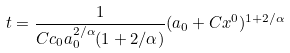<formula> <loc_0><loc_0><loc_500><loc_500>t = \frac { 1 } { C c _ { 0 } a _ { 0 } ^ { 2 / \alpha } ( 1 + 2 / \alpha ) } ( a _ { 0 } + C x ^ { 0 } ) ^ { 1 + 2 / \alpha }</formula> 